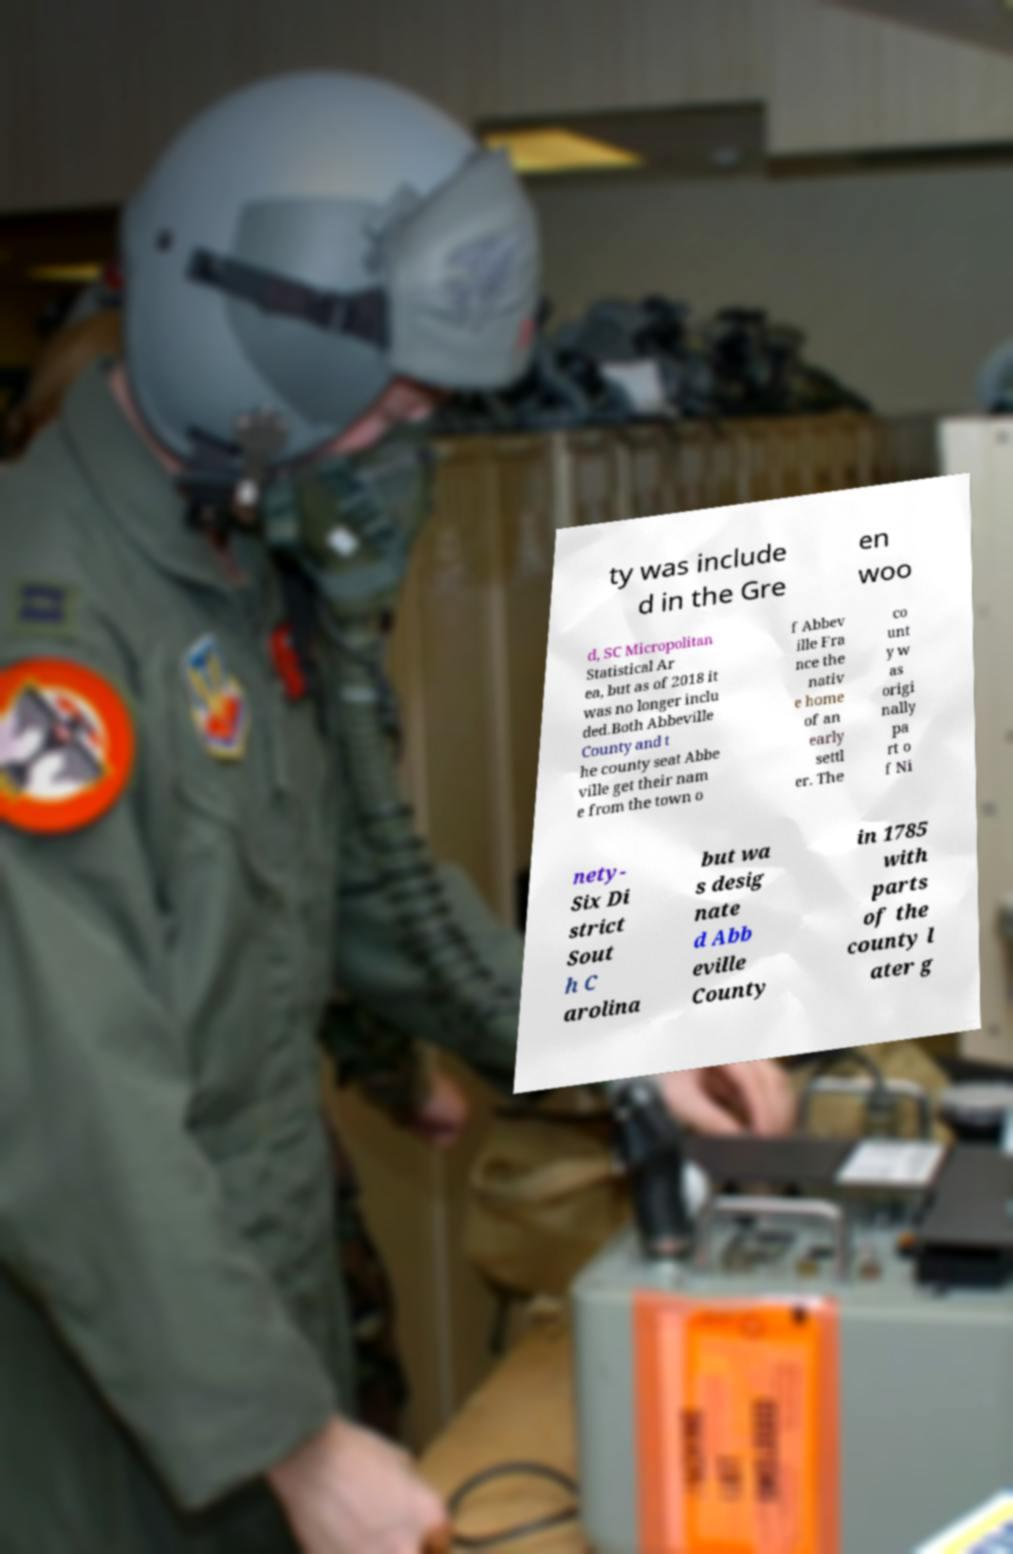Could you assist in decoding the text presented in this image and type it out clearly? ty was include d in the Gre en woo d, SC Micropolitan Statistical Ar ea, but as of 2018 it was no longer inclu ded.Both Abbeville County and t he county seat Abbe ville get their nam e from the town o f Abbev ille Fra nce the nativ e home of an early settl er. The co unt y w as origi nally pa rt o f Ni nety- Six Di strict Sout h C arolina but wa s desig nate d Abb eville County in 1785 with parts of the county l ater g 